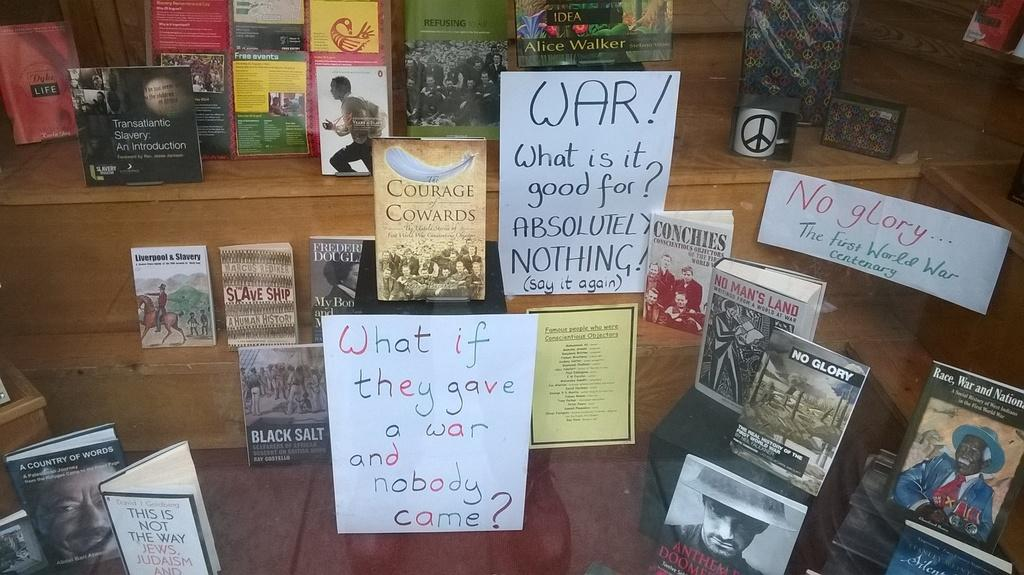<image>
Present a compact description of the photo's key features. A display of books that are about Peace and War 